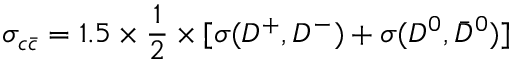<formula> <loc_0><loc_0><loc_500><loc_500>\sigma _ { c \bar { c } } = 1 . 5 \times { \frac { 1 } { 2 } } \times [ { \sigma ( D ^ { + } , D ^ { - } ) + \sigma ( D ^ { 0 } , \bar { D } ^ { 0 } ) ] }</formula> 